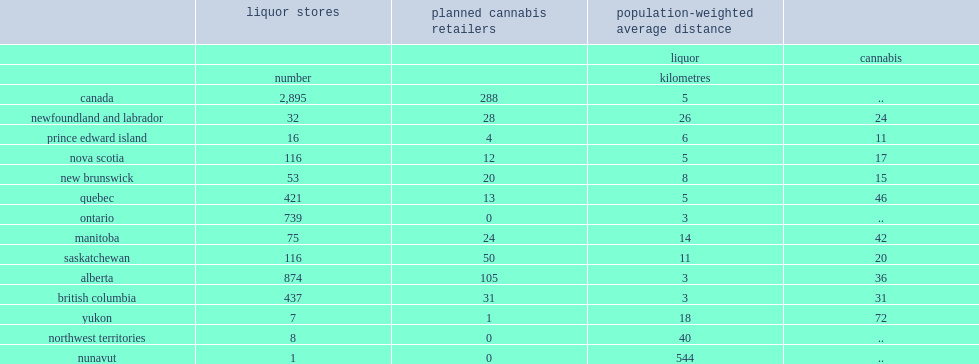How many liquor stores are in canada? 2895.0. How many kilometres are the population-weighted average distance between canadians and the nearest liquor store? 5.0. How many open cannabis retail outlets will be in the fourth quarter in canada? 288.0. 